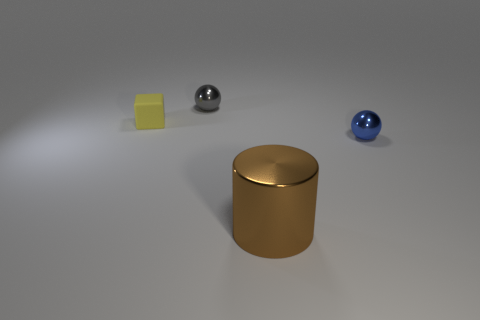Is there any other thing that is made of the same material as the yellow object?
Keep it short and to the point. No. There is a small shiny thing that is right of the big cylinder; is it the same shape as the tiny gray metallic object?
Provide a succinct answer. Yes. What color is the rubber block that is the same size as the blue sphere?
Your answer should be very brief. Yellow. What number of cubes are there?
Provide a succinct answer. 1. Is the sphere on the left side of the blue metal object made of the same material as the small cube?
Give a very brief answer. No. What material is the small object that is both in front of the small gray metal object and left of the blue thing?
Ensure brevity in your answer.  Rubber. There is a tiny object that is to the right of the metallic thing that is behind the blue metal ball; what is it made of?
Provide a succinct answer. Metal. There is a sphere that is left of the small sphere in front of the small ball behind the blue ball; how big is it?
Make the answer very short. Small. How many big brown objects have the same material as the cube?
Your response must be concise. 0. There is a shiny thing that is behind the small metallic thing that is to the right of the gray object; what color is it?
Provide a short and direct response. Gray. 